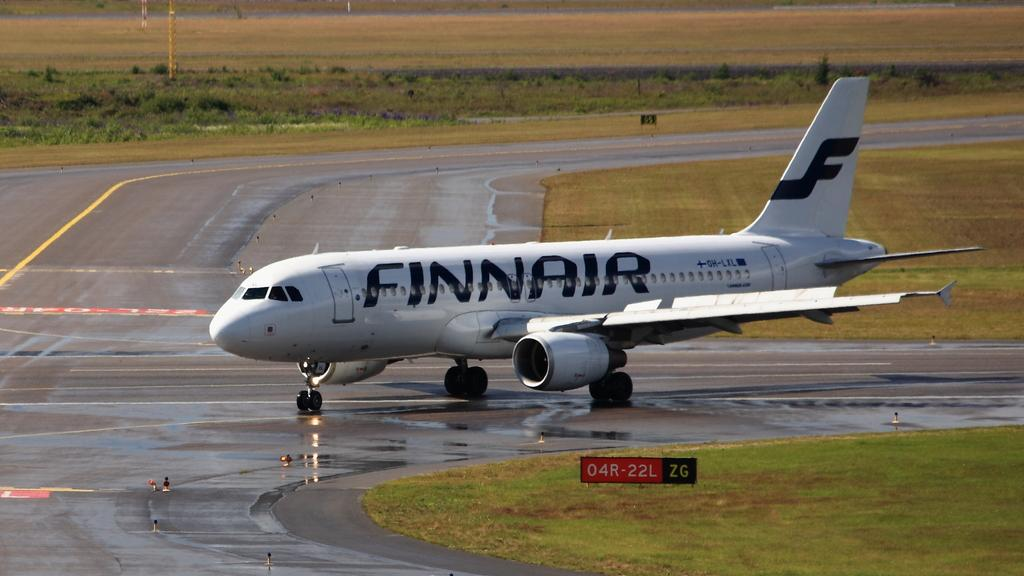Provide a one-sentence caption for the provided image. The white Finnair plane is on the tarmac. 